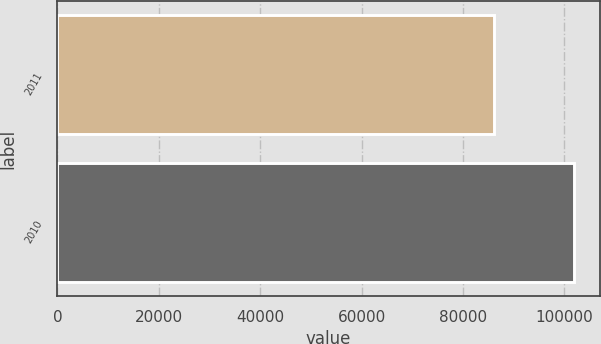<chart> <loc_0><loc_0><loc_500><loc_500><bar_chart><fcel>2011<fcel>2010<nl><fcel>86143<fcel>101831<nl></chart> 